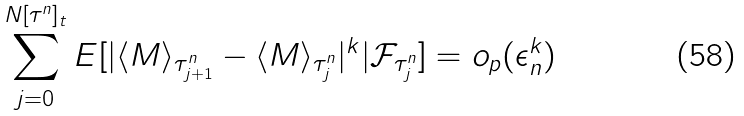Convert formula to latex. <formula><loc_0><loc_0><loc_500><loc_500>\sum _ { j = 0 } ^ { N [ \tau ^ { n } ] _ { t } } E [ | \langle M \rangle _ { \tau _ { j + 1 } ^ { n } } - \langle M \rangle _ { \tau _ { j } ^ { n } } | ^ { k } | \mathcal { F } _ { \tau _ { j } ^ { n } } ] = o _ { p } ( \epsilon _ { n } ^ { k } )</formula> 